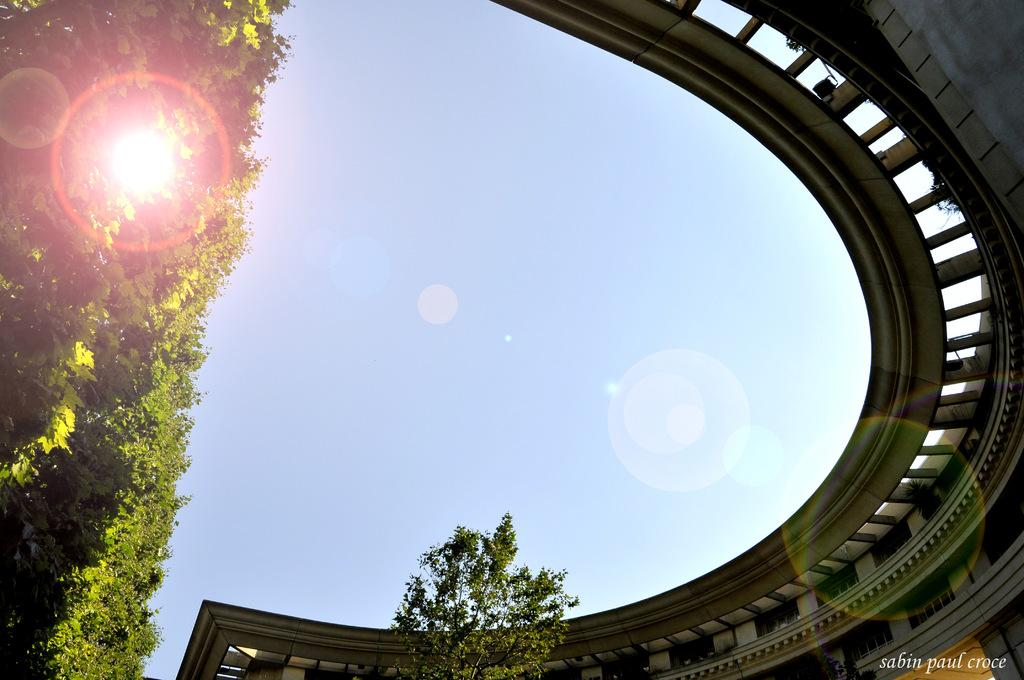What color is the sky in the image? The sky in the image is blue. What can be seen to the right of the image? There is a building to the right of the image. What type of vegetation is present to the left of the image? There are many trees to the left of the image. Is there any text or logo visible in the image? Yes, there is a watermark visible in the image. What type of chalk is being used to draw on the building in the image? There is no chalk or drawing present on the building in the image. Can you tell me how many kettles are visible in the image? There are no kettles visible in the image. 